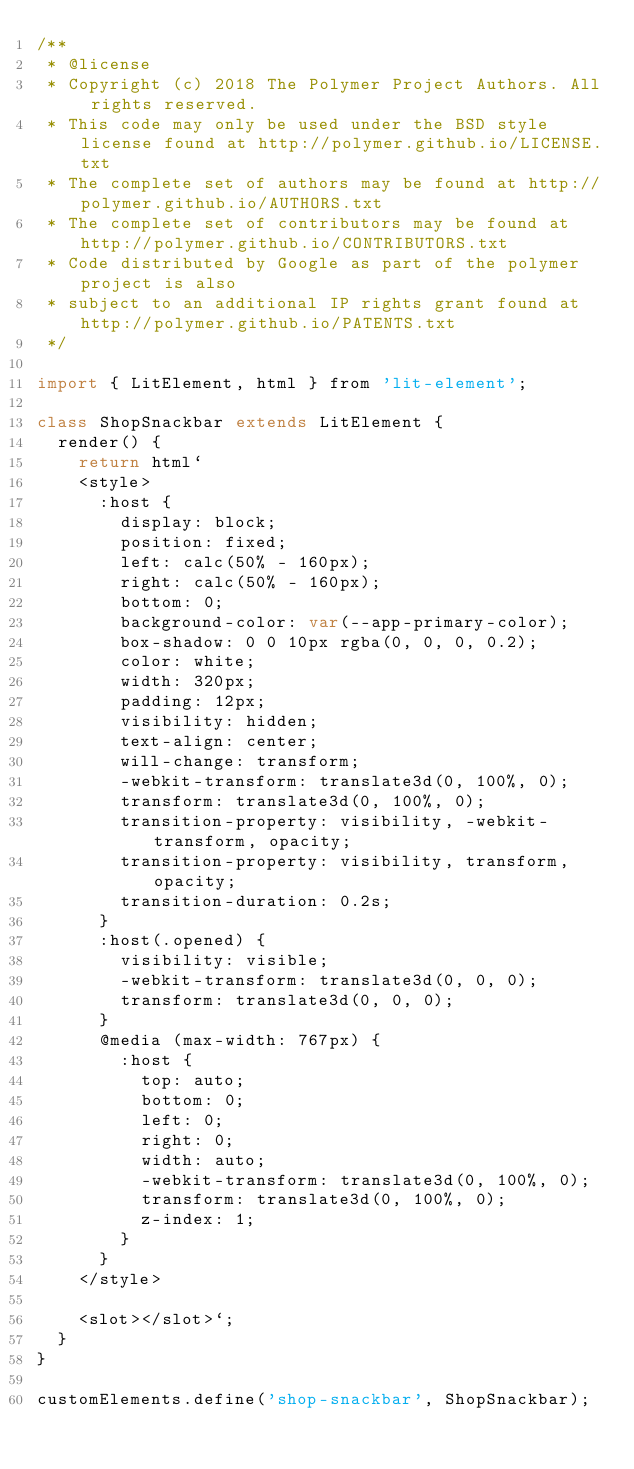<code> <loc_0><loc_0><loc_500><loc_500><_JavaScript_>/**
 * @license
 * Copyright (c) 2018 The Polymer Project Authors. All rights reserved.
 * This code may only be used under the BSD style license found at http://polymer.github.io/LICENSE.txt
 * The complete set of authors may be found at http://polymer.github.io/AUTHORS.txt
 * The complete set of contributors may be found at http://polymer.github.io/CONTRIBUTORS.txt
 * Code distributed by Google as part of the polymer project is also
 * subject to an additional IP rights grant found at http://polymer.github.io/PATENTS.txt
 */

import { LitElement, html } from 'lit-element';

class ShopSnackbar extends LitElement {
  render() {
    return html`
    <style>
      :host {
        display: block;
        position: fixed;
        left: calc(50% - 160px);
        right: calc(50% - 160px);
        bottom: 0;
        background-color: var(--app-primary-color);
        box-shadow: 0 0 10px rgba(0, 0, 0, 0.2);
        color: white;
        width: 320px;
        padding: 12px;
        visibility: hidden;
        text-align: center;
        will-change: transform;
        -webkit-transform: translate3d(0, 100%, 0);
        transform: translate3d(0, 100%, 0);
        transition-property: visibility, -webkit-transform, opacity;
        transition-property: visibility, transform, opacity;
        transition-duration: 0.2s;
      }
      :host(.opened) {
        visibility: visible;
        -webkit-transform: translate3d(0, 0, 0);
        transform: translate3d(0, 0, 0);
      }
      @media (max-width: 767px) {
        :host {
          top: auto;
          bottom: 0;
          left: 0;
          right: 0;
          width: auto;
          -webkit-transform: translate3d(0, 100%, 0);
          transform: translate3d(0, 100%, 0);
          z-index: 1;
        }
      }
    </style>

    <slot></slot>`;
  }
}

customElements.define('shop-snackbar', ShopSnackbar);
</code> 